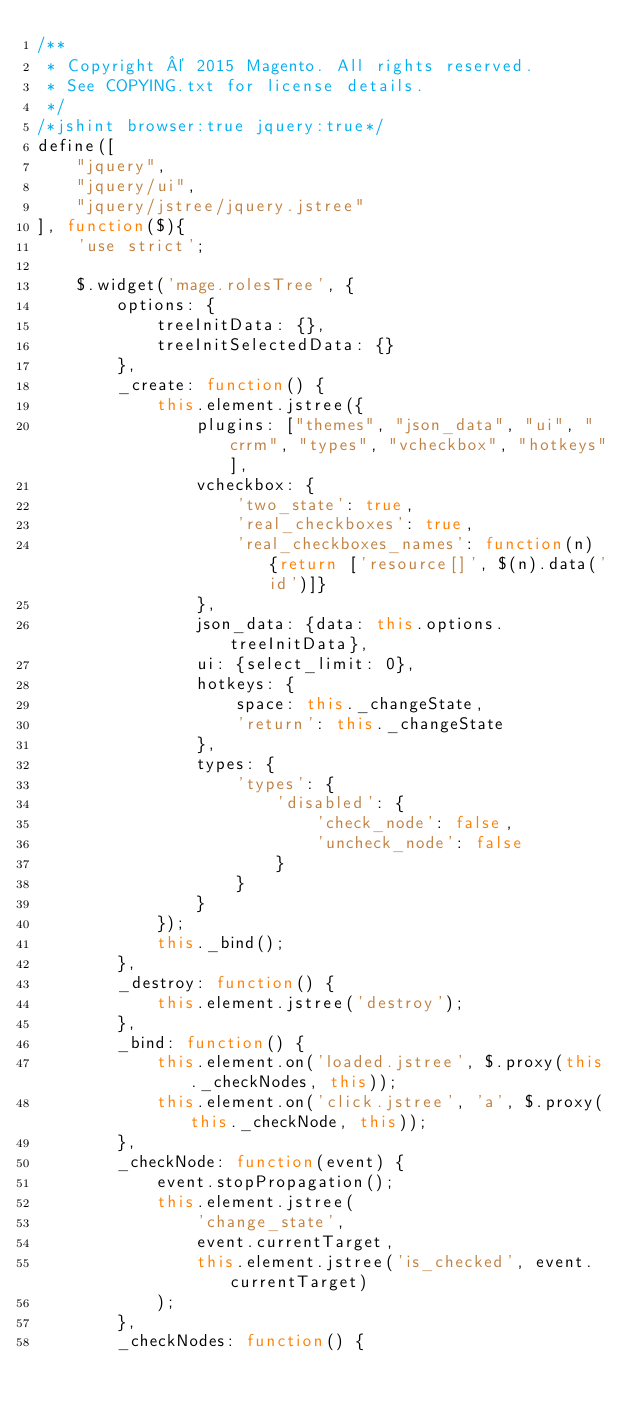<code> <loc_0><loc_0><loc_500><loc_500><_JavaScript_>/**
 * Copyright © 2015 Magento. All rights reserved.
 * See COPYING.txt for license details.
 */
/*jshint browser:true jquery:true*/
define([
    "jquery",
    "jquery/ui",
    "jquery/jstree/jquery.jstree"
], function($){
    'use strict';

    $.widget('mage.rolesTree', {
        options: {
            treeInitData: {},
            treeInitSelectedData: {}
        },
        _create: function() {
            this.element.jstree({
                plugins: ["themes", "json_data", "ui", "crrm", "types", "vcheckbox", "hotkeys"],
                vcheckbox: {
                    'two_state': true,
                    'real_checkboxes': true,
                    'real_checkboxes_names': function(n) {return ['resource[]', $(n).data('id')]}
                },
                json_data: {data: this.options.treeInitData},
                ui: {select_limit: 0},
                hotkeys: {
                    space: this._changeState,
                    'return': this._changeState
                },
                types: {
                    'types': {
                        'disabled': {
                            'check_node': false,
                            'uncheck_node': false
                        }
                    }
                }
            });
            this._bind();
        },
        _destroy: function() {
            this.element.jstree('destroy');
        },
        _bind: function() {
            this.element.on('loaded.jstree', $.proxy(this._checkNodes, this));
            this.element.on('click.jstree', 'a', $.proxy(this._checkNode, this));
        },
        _checkNode: function(event) {
            event.stopPropagation();
            this.element.jstree(
                'change_state',
                event.currentTarget,
                this.element.jstree('is_checked', event.currentTarget)
            );
        },
        _checkNodes: function() {</code> 